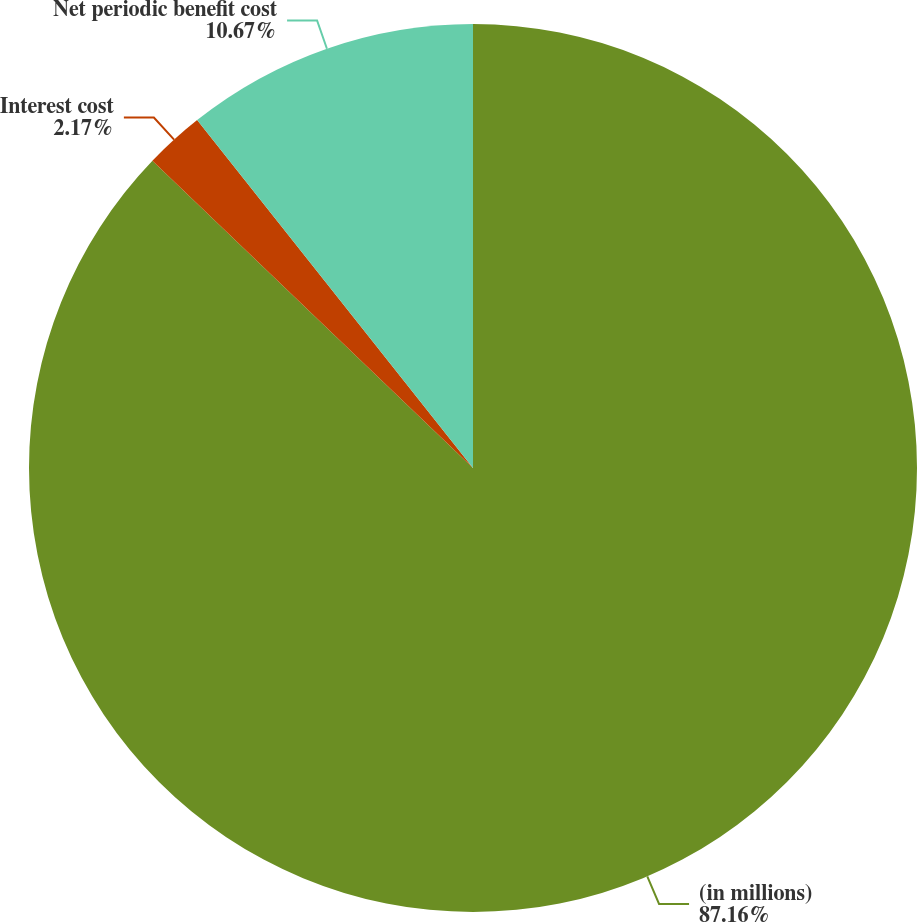Convert chart to OTSL. <chart><loc_0><loc_0><loc_500><loc_500><pie_chart><fcel>(in millions)<fcel>Interest cost<fcel>Net periodic benefit cost<nl><fcel>87.16%<fcel>2.17%<fcel>10.67%<nl></chart> 